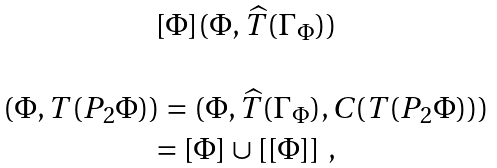Convert formula to latex. <formula><loc_0><loc_0><loc_500><loc_500>\begin{array} { c } [ \Phi ] ( \Phi , \widehat { T } ( \Gamma _ { \Phi } ) ) \\ \quad \\ ( \Phi , T ( P _ { 2 } \Phi ) ) = ( \Phi , \widehat { T } ( \Gamma _ { \Phi } ) , C ( T ( P _ { 2 } \Phi ) ) ) \\ = [ \Phi ] \cup [ [ \Phi ] ] \ , \end{array}</formula> 